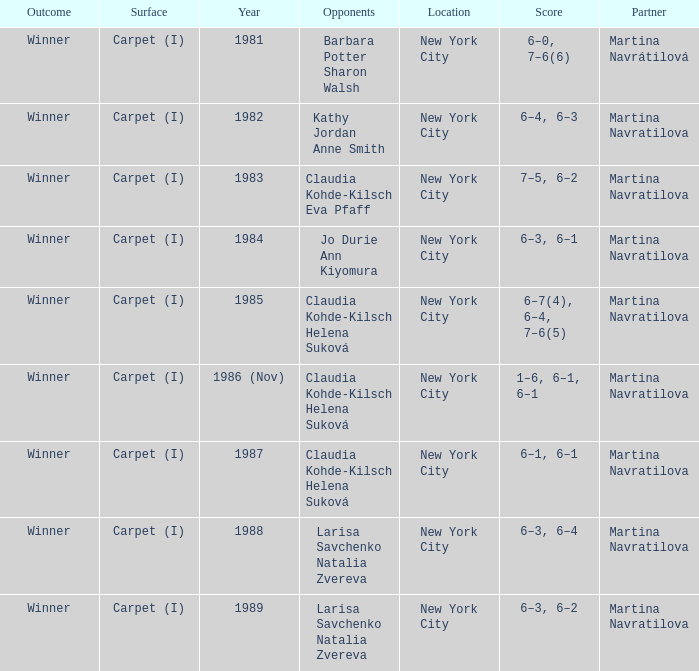Who were all of the opponents in 1984? Jo Durie Ann Kiyomura. 